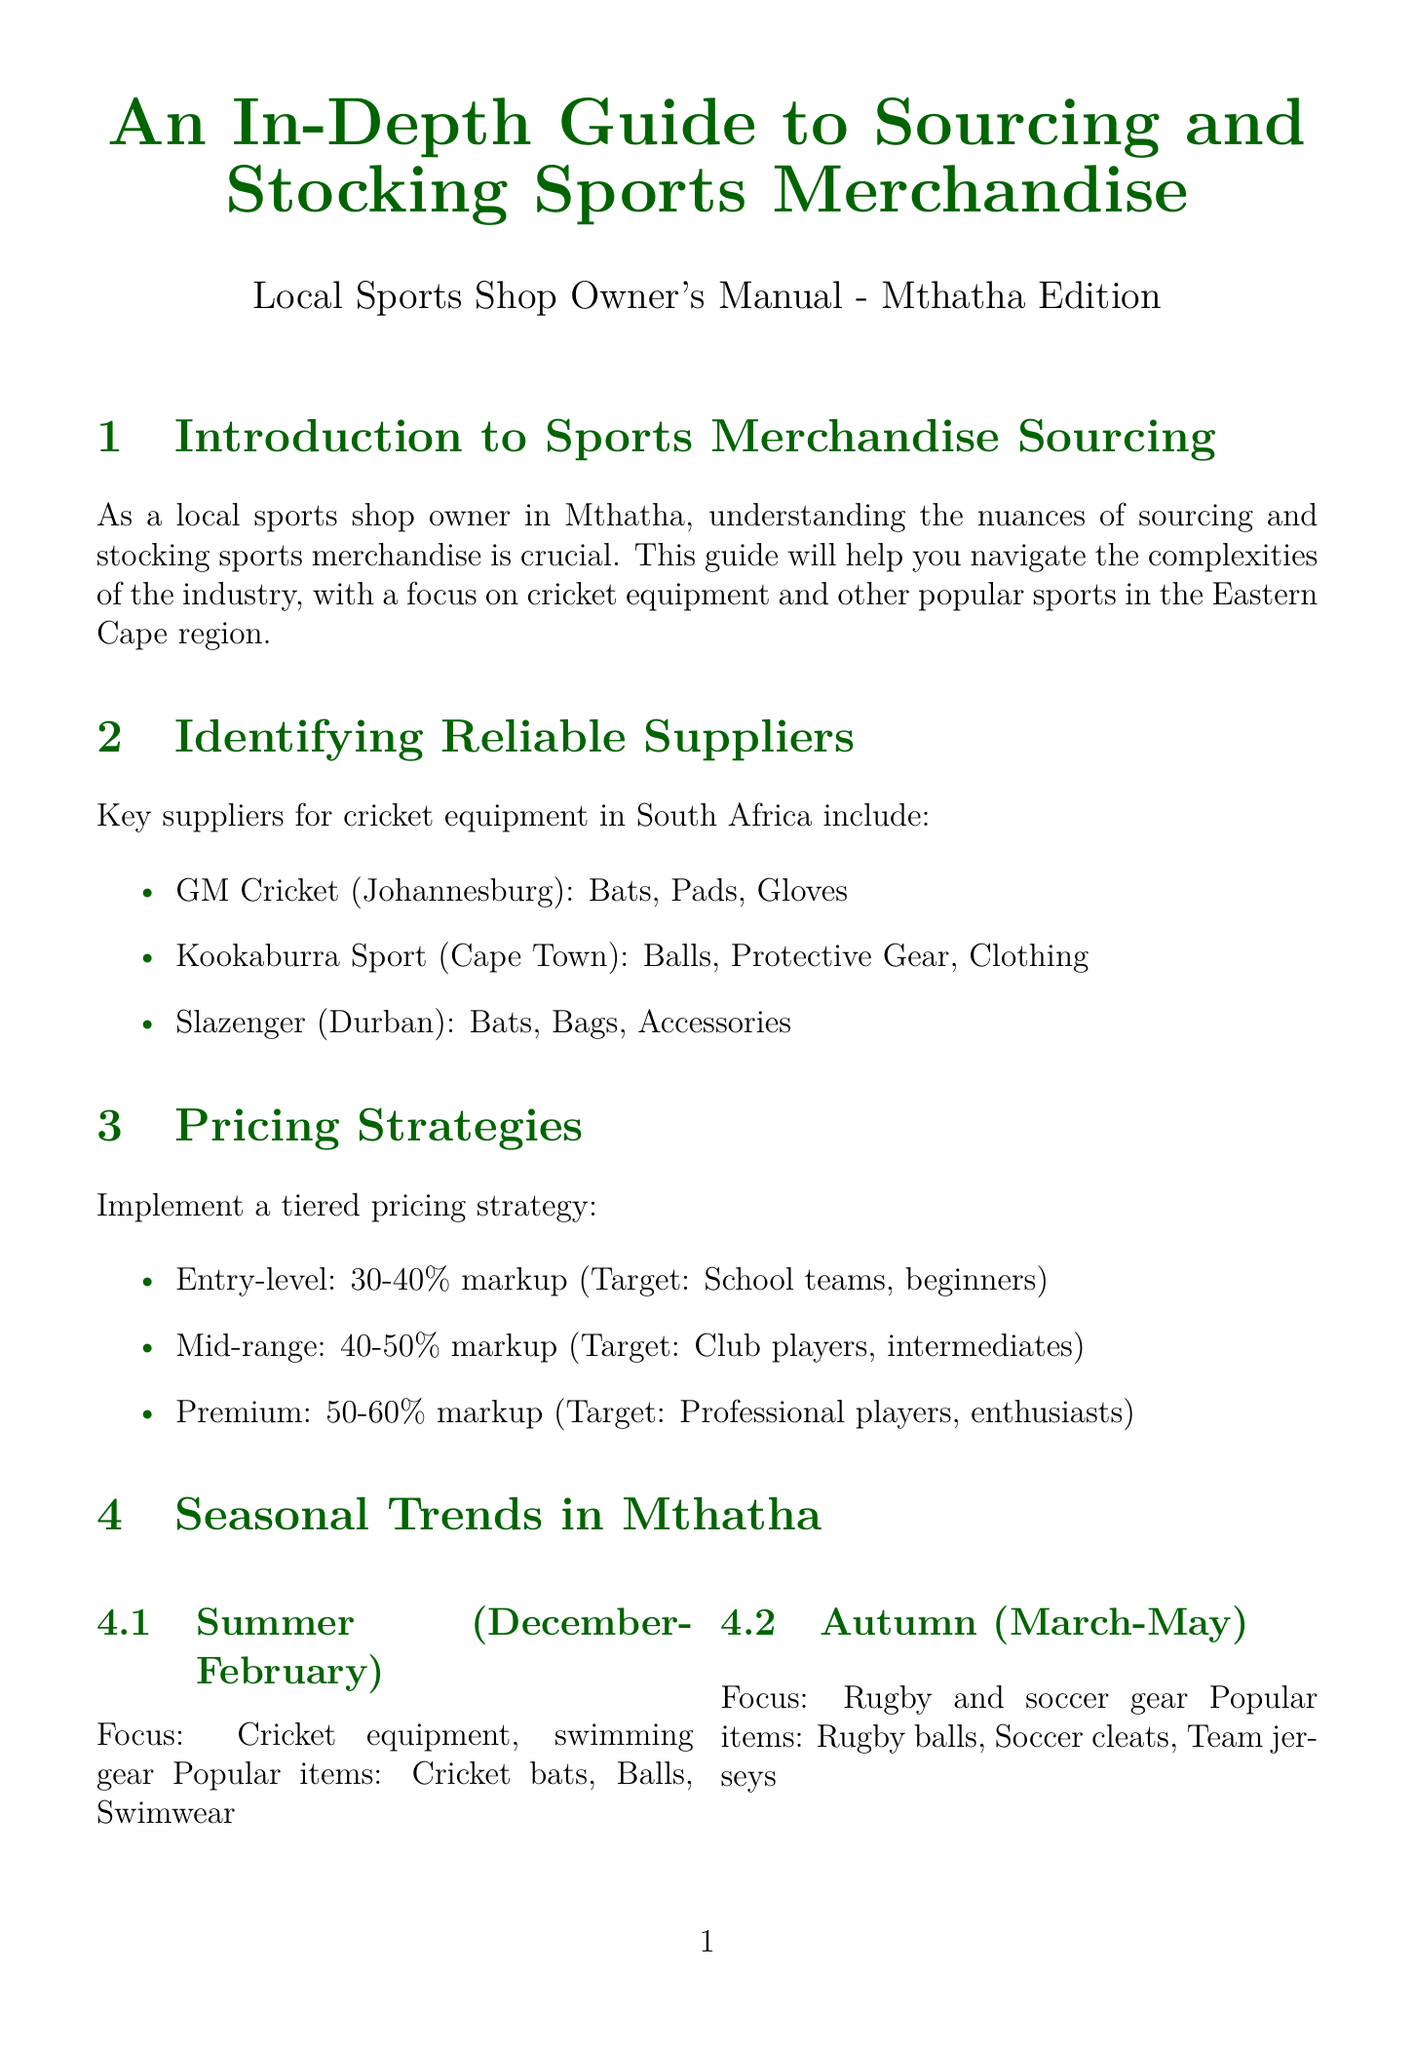What are the key suppliers for cricket equipment? The document lists GM Cricket, Kookaburra Sport, and Slazenger as key suppliers.
Answer: GM Cricket, Kookaburra Sport, Slazenger What is the focus during summer in Mthatha? The focus during summer, as stated in the document, is on cricket equipment and swimming gear.
Answer: Cricket equipment, swimming gear What is the target audience for the premium pricing strategy? The document specifies that the target audience for the premium pricing strategy is professional players and enthusiasts.
Answer: Professional players, enthusiasts What is the estimated population of Mthatha? The document states the population of Mthatha is approximately 150,000.
Answer: Approximately 150,000 What technique is suggested for effective inventory management? The document recommends using point-of-sale software like Vend or Lightspeed as one of the techniques for inventory management.
Answer: Point-of-sale software like Vend or Lightspeed What are popular items in spring? Popular items during spring include training aids, running shoes, and cricket protective gear according to the document.
Answer: Training aids, running shoes, cricket protective gear Which organization is mentioned for networking opportunities? The Sporting Goods Federation of South Africa is mentioned as a resource for networking opportunities.
Answer: Sporting Goods Federation of South Africa What is a recommended marketing tactic? Sponsoring local cricket teams and events is listed as a recommended tactic for marketing and promotion.
Answer: Sponsor local cricket teams and events 